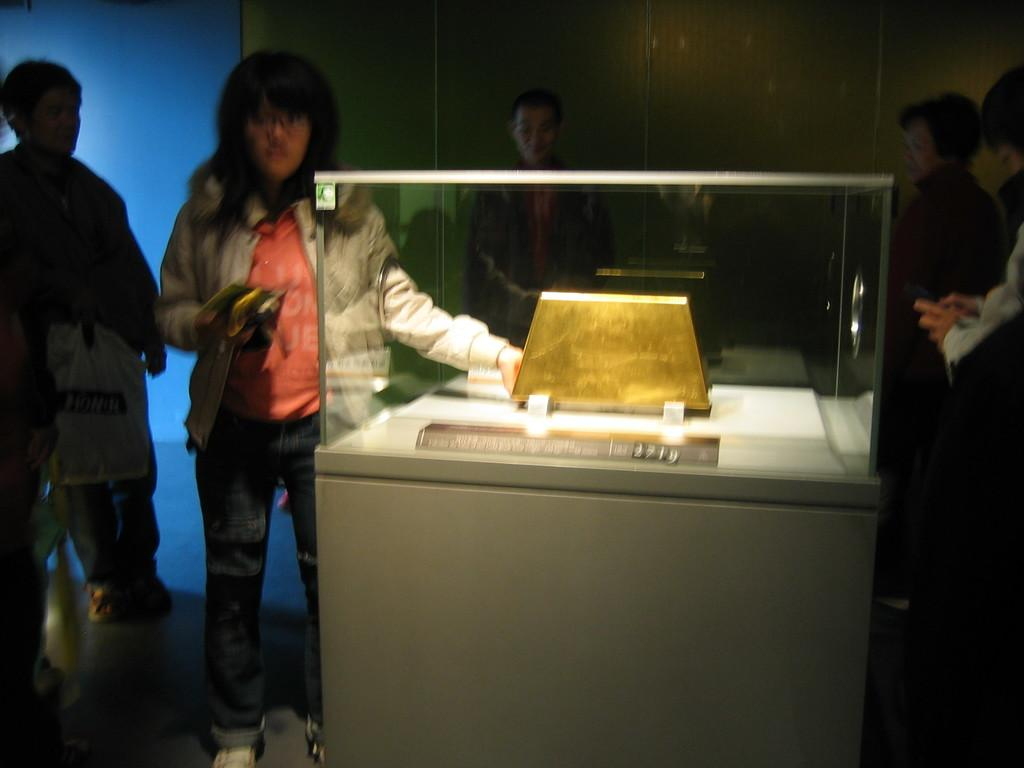How many people are present in the image? There are five persons standing in the image. Where are the persons standing? The persons are standing on the floor. What can be seen in the image besides the people? There is an object and a name board in the image. How are the object and name board displayed? The object and name board are kept in a glass box. What is visible in the background of the image? There is a wall in the background of the image. How many horses are visible in the image? There are no horses present in the image. Is there a sink visible in the image? There is no sink present in the image. 